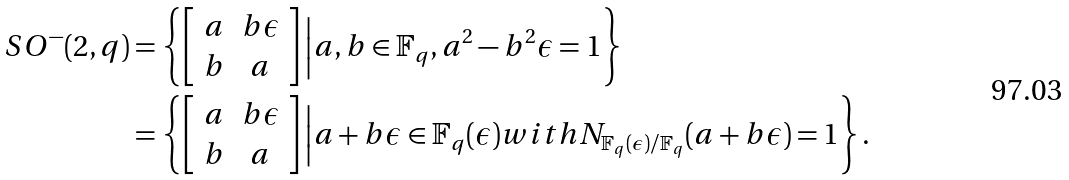Convert formula to latex. <formula><loc_0><loc_0><loc_500><loc_500>S O ^ { - } ( 2 , q ) & = \left \{ \left [ \begin{array} { c c } a & b \epsilon \\ b & a \\ \end{array} \right ] \Big { | } a , b \in \mathbb { F } _ { q } , a ^ { 2 } - b ^ { 2 } \epsilon = 1 \right \} \\ & = \left \{ \left [ \begin{array} { c c } a & b \epsilon \\ b & a \\ \end{array} \right ] \Big { | } a + b \epsilon \in \mathbb { F } _ { q } ( \epsilon ) w i t h N _ { \mathbb { F } _ { q } ( \epsilon ) / \mathbb { F } _ { q } } ( a + b \epsilon ) = 1 \right \} .</formula> 